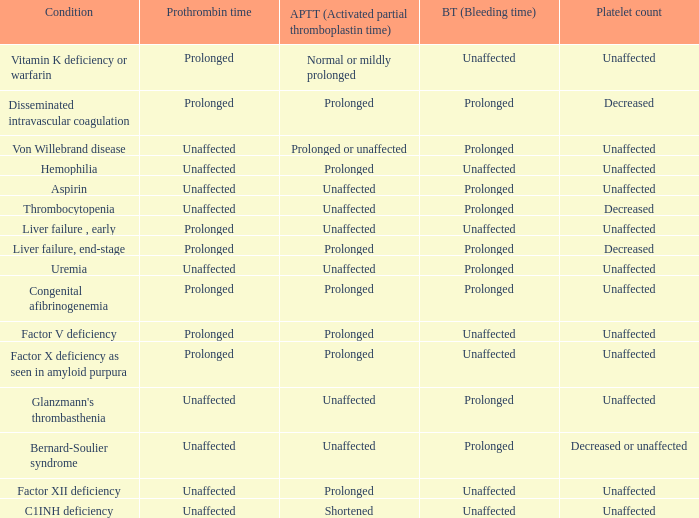Which Bleeding has a Condition of congenital afibrinogenemia? Prolonged. 